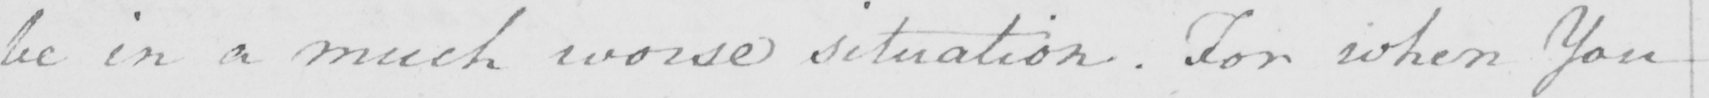Please transcribe the handwritten text in this image. be in a much worse situation . For when You 